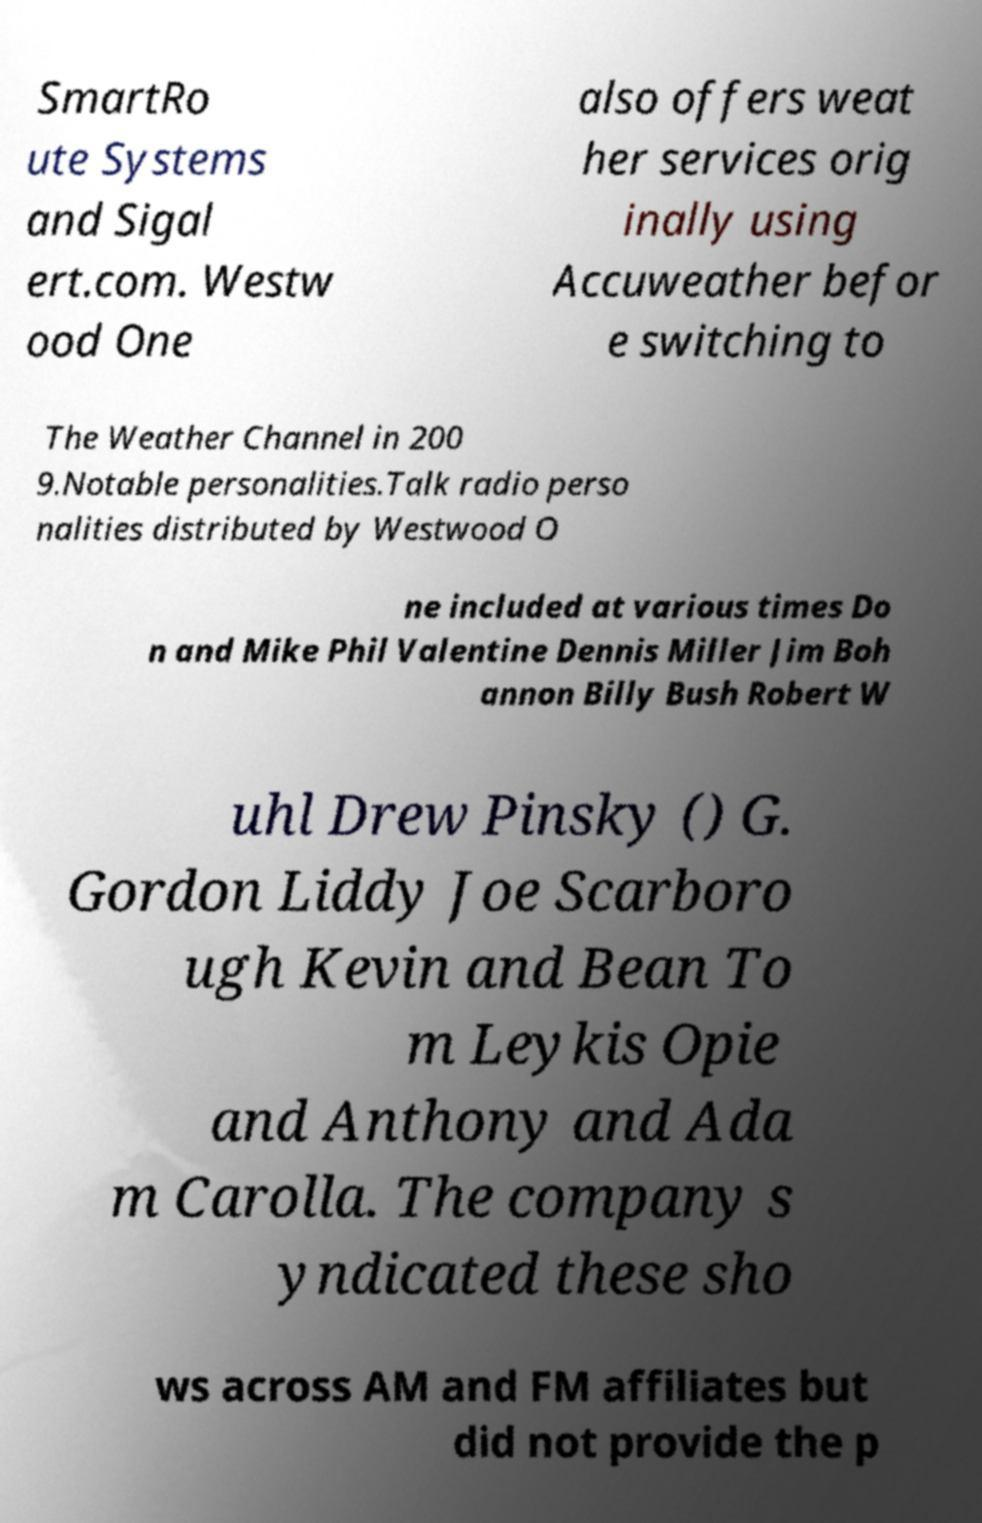Please read and relay the text visible in this image. What does it say? SmartRo ute Systems and Sigal ert.com. Westw ood One also offers weat her services orig inally using Accuweather befor e switching to The Weather Channel in 200 9.Notable personalities.Talk radio perso nalities distributed by Westwood O ne included at various times Do n and Mike Phil Valentine Dennis Miller Jim Boh annon Billy Bush Robert W uhl Drew Pinsky () G. Gordon Liddy Joe Scarboro ugh Kevin and Bean To m Leykis Opie and Anthony and Ada m Carolla. The company s yndicated these sho ws across AM and FM affiliates but did not provide the p 